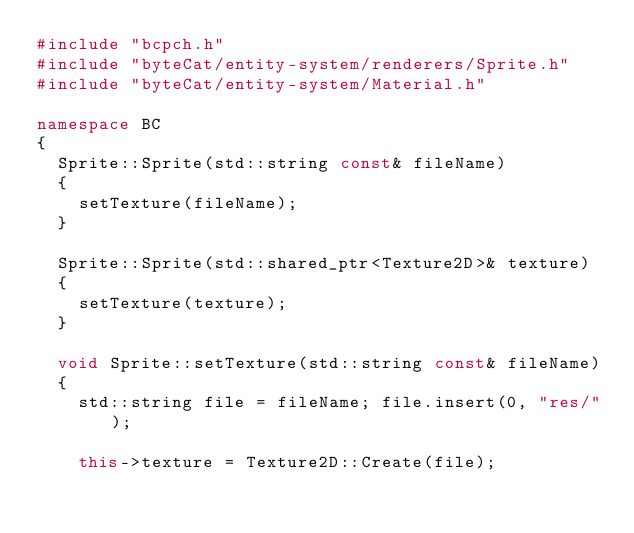<code> <loc_0><loc_0><loc_500><loc_500><_C++_>#include "bcpch.h"
#include "byteCat/entity-system/renderers/Sprite.h"
#include "byteCat/entity-system/Material.h"

namespace BC
{
	Sprite::Sprite(std::string const& fileName)
	{
		setTexture(fileName);
	}

	Sprite::Sprite(std::shared_ptr<Texture2D>& texture)
	{
		setTexture(texture);
	}

	void Sprite::setTexture(std::string const& fileName)
	{
		std::string file = fileName; file.insert(0, "res/");
		
		this->texture = Texture2D::Create(file);</code> 